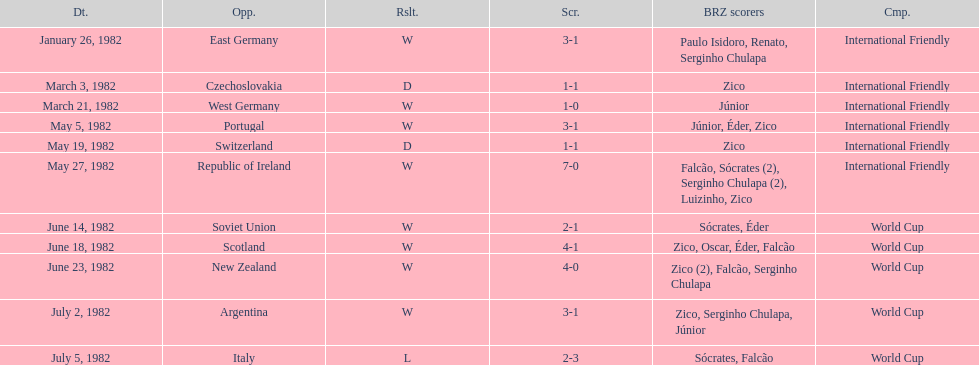Can you give me this table as a dict? {'header': ['Dt.', 'Opp.', 'Rslt.', 'Scr.', 'BRZ scorers', 'Cmp.'], 'rows': [['January 26, 1982', 'East Germany', 'W', '3-1', 'Paulo Isidoro, Renato, Serginho Chulapa', 'International Friendly'], ['March 3, 1982', 'Czechoslovakia', 'D', '1-1', 'Zico', 'International Friendly'], ['March 21, 1982', 'West Germany', 'W', '1-0', 'Júnior', 'International Friendly'], ['May 5, 1982', 'Portugal', 'W', '3-1', 'Júnior, Éder, Zico', 'International Friendly'], ['May 19, 1982', 'Switzerland', 'D', '1-1', 'Zico', 'International Friendly'], ['May 27, 1982', 'Republic of Ireland', 'W', '7-0', 'Falcão, Sócrates (2), Serginho Chulapa (2), Luizinho, Zico', 'International Friendly'], ['June 14, 1982', 'Soviet Union', 'W', '2-1', 'Sócrates, Éder', 'World Cup'], ['June 18, 1982', 'Scotland', 'W', '4-1', 'Zico, Oscar, Éder, Falcão', 'World Cup'], ['June 23, 1982', 'New Zealand', 'W', '4-0', 'Zico (2), Falcão, Serginho Chulapa', 'World Cup'], ['July 2, 1982', 'Argentina', 'W', '3-1', 'Zico, Serginho Chulapa, Júnior', 'World Cup'], ['July 5, 1982', 'Italy', 'L', '2-3', 'Sócrates, Falcão', 'World Cup']]} What date is positioned at the highest point of the list? January 26, 1982. 